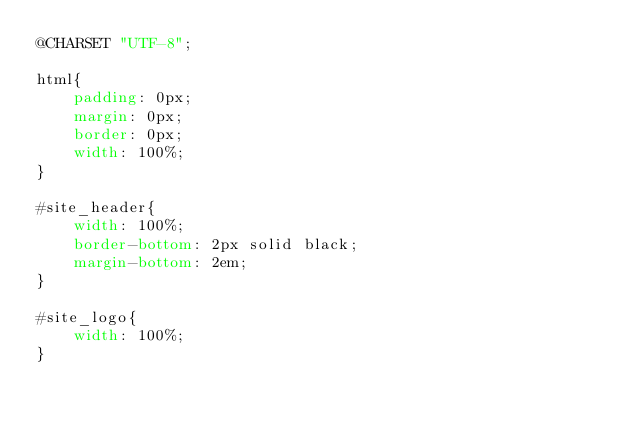<code> <loc_0><loc_0><loc_500><loc_500><_CSS_>@CHARSET "UTF-8";

html{
	padding: 0px;
	margin: 0px;
	border: 0px;
	width: 100%;
}

#site_header{
	width: 100%;
	border-bottom: 2px solid black;
	margin-bottom: 2em;
}

#site_logo{
	width: 100%;
}
</code> 